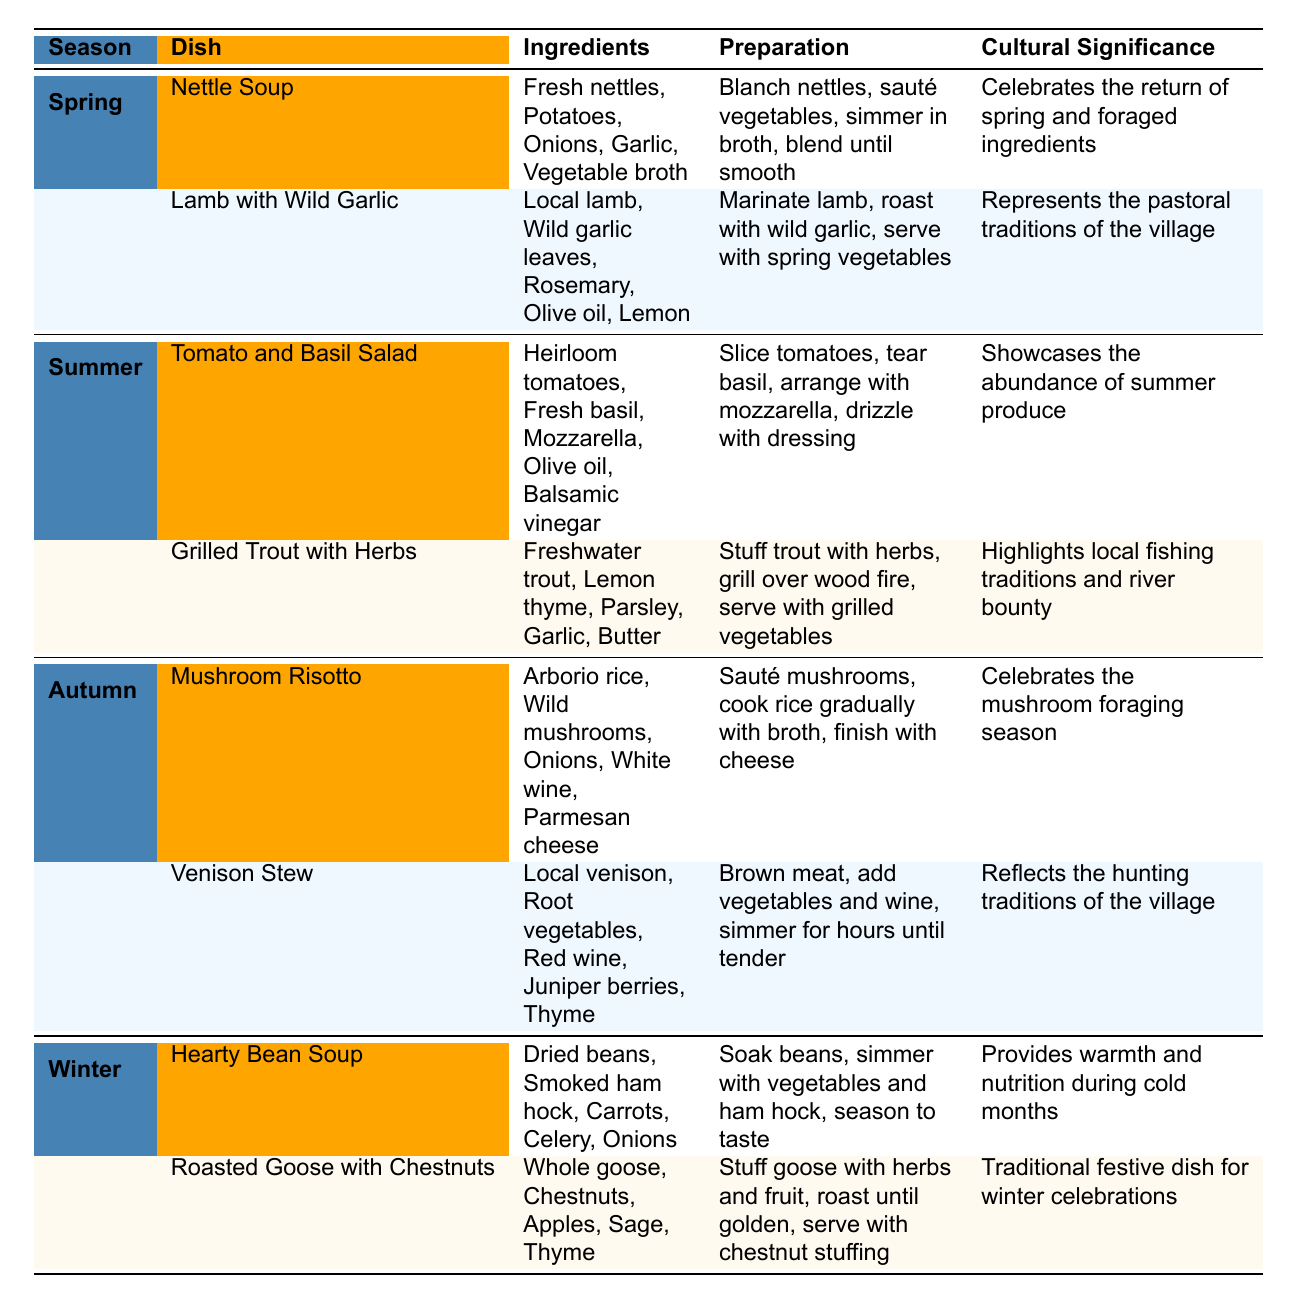What dishes are served in spring? In the table under the spring season, there are two dishes listed: Nettle Soup and Lamb with Wild Garlic.
Answer: Nettle Soup and Lamb with Wild Garlic What are the main ingredients in Mushroom Risotto? The table specifies that Mushroom Risotto consists of Arborio rice, Wild mushrooms, Onions, White wine, and Parmesan cheese.
Answer: Arborio rice, Wild mushrooms, Onions, White wine, Parmesan cheese Is grilled trout included in the winter dishes? According to the table, Grilled Trout with Herbs is listed under the summer dishes, not the winter dishes. Therefore, it is not included in the winter dishes.
Answer: No Which dish has the cultural significance related to hunting traditions? The Venison Stew is explicitly mentioned as reflecting the hunting traditions of the village in the cultural significance column.
Answer: Venison Stew How many total dishes are listed in the summer season? The summer season contains two dishes: Tomato and Basil Salad and Grilled Trout with Herbs, making a total of two dishes.
Answer: 2 What is the preparation method for Roasted Goose with Chestnuts? The preparation details for Roasted Goose with Chestnuts include stuffing the goose with herbs and fruit, roasting it until golden, and serving it with chestnut stuffing.
Answer: Stuff goose, roast until golden, serve with chestnut stuffing Which season features the most dishes, and how many are there? Each season has two dishes listed in the table, so no season features more than the others. Each season has a total of two dishes.
Answer: All seasons have 2 dishes What are the differences in cultural significance between summer and winter dishes? In summer, the cultural significance emphasizes showcasing the abundance of produce and local fishing traditions, while in winter, it focuses on warmth, nutrition, and festive traditions.
Answer: Different emphases: summer on abundance, winter on warmth and celebration Which dish involves foraged ingredients and what is its preparation? Nettle Soup is cited as celebrating foraged ingredients and its preparation includes blanching nettles, sautéing vegetables, simmering them in broth, and blending until smooth.
Answer: Nettle Soup; blend nettles and vegetables in broth Is there a dish that uses juniper berries? Yes, the Venison Stew is the dish that includes juniper berries as part of its ingredients.
Answer: Yes, Venison Stew 